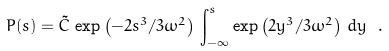<formula> <loc_0><loc_0><loc_500><loc_500>P ( s ) = { \tilde { C } } \, \exp \left ( - 2 s ^ { 3 } / 3 \omega ^ { 2 } \right ) \, \int _ { - \infty } ^ { s } \exp \left ( 2 y ^ { 3 } / 3 \omega ^ { 2 } \right ) \, d y \ .</formula> 